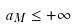<formula> <loc_0><loc_0><loc_500><loc_500>a _ { M } \leq + \infty</formula> 